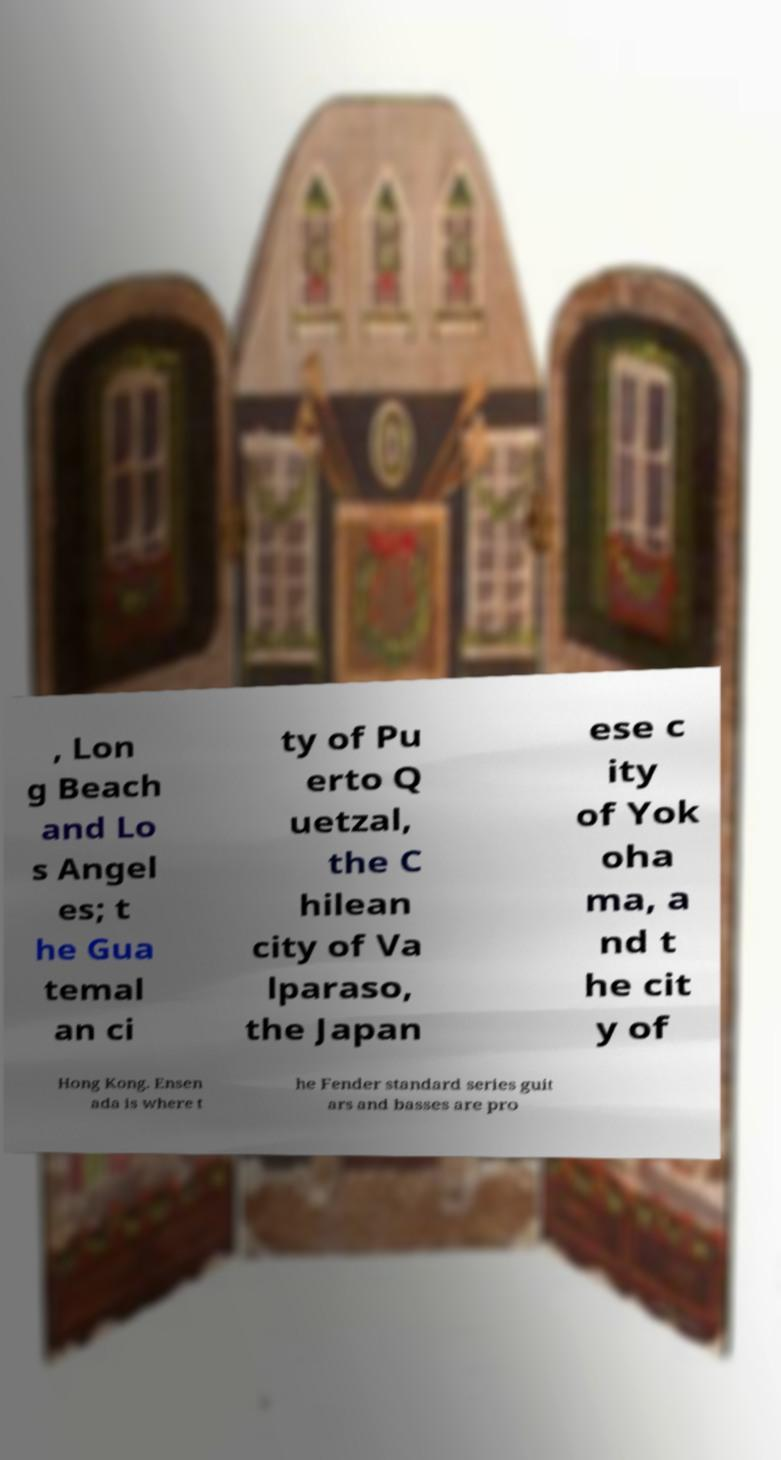What messages or text are displayed in this image? I need them in a readable, typed format. , Lon g Beach and Lo s Angel es; t he Gua temal an ci ty of Pu erto Q uetzal, the C hilean city of Va lparaso, the Japan ese c ity of Yok oha ma, a nd t he cit y of Hong Kong. Ensen ada is where t he Fender standard series guit ars and basses are pro 